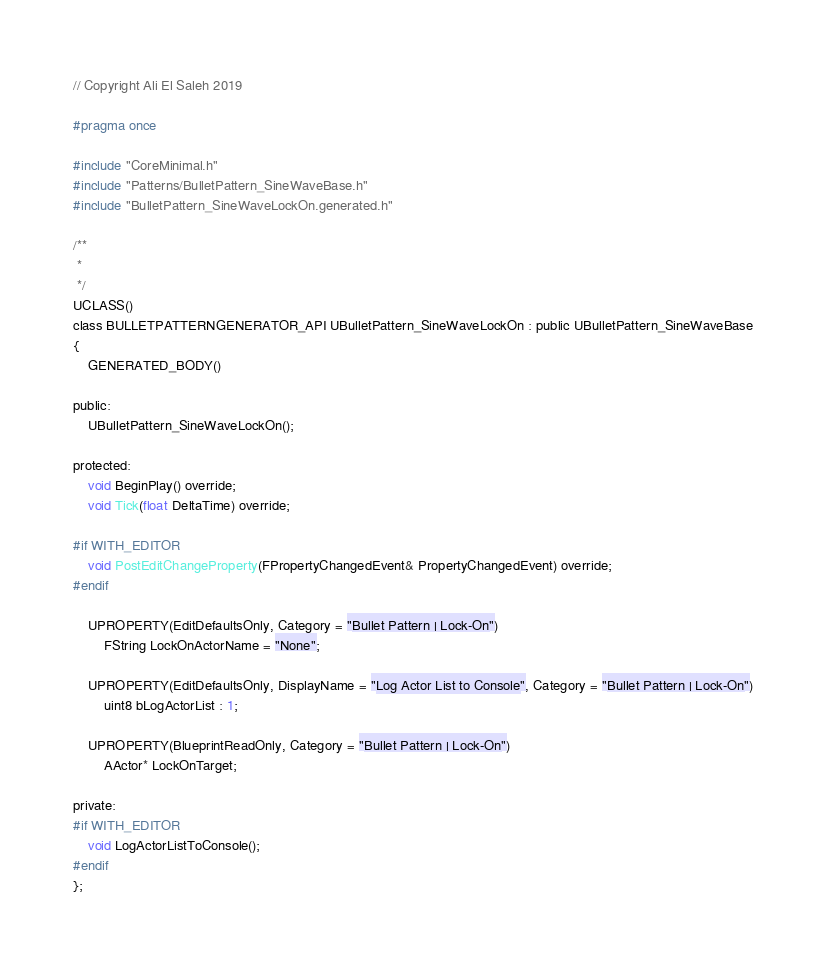Convert code to text. <code><loc_0><loc_0><loc_500><loc_500><_C_>// Copyright Ali El Saleh 2019

#pragma once

#include "CoreMinimal.h"
#include "Patterns/BulletPattern_SineWaveBase.h"
#include "BulletPattern_SineWaveLockOn.generated.h"

/**
 * 
 */
UCLASS()
class BULLETPATTERNGENERATOR_API UBulletPattern_SineWaveLockOn : public UBulletPattern_SineWaveBase
{
	GENERATED_BODY()

public:
	UBulletPattern_SineWaveLockOn();

protected:
	void BeginPlay() override;
	void Tick(float DeltaTime) override;
	
#if WITH_EDITOR
	void PostEditChangeProperty(FPropertyChangedEvent& PropertyChangedEvent) override;
#endif

	UPROPERTY(EditDefaultsOnly, Category = "Bullet Pattern | Lock-On")
		FString LockOnActorName = "None";

	UPROPERTY(EditDefaultsOnly, DisplayName = "Log Actor List to Console", Category = "Bullet Pattern | Lock-On")
		uint8 bLogActorList : 1;

	UPROPERTY(BlueprintReadOnly, Category = "Bullet Pattern | Lock-On")
		AActor* LockOnTarget;

private:
#if WITH_EDITOR
	void LogActorListToConsole();
#endif
};
</code> 